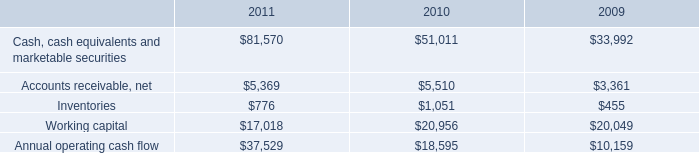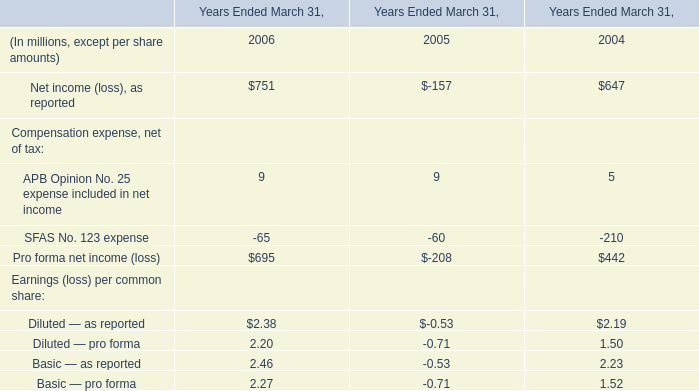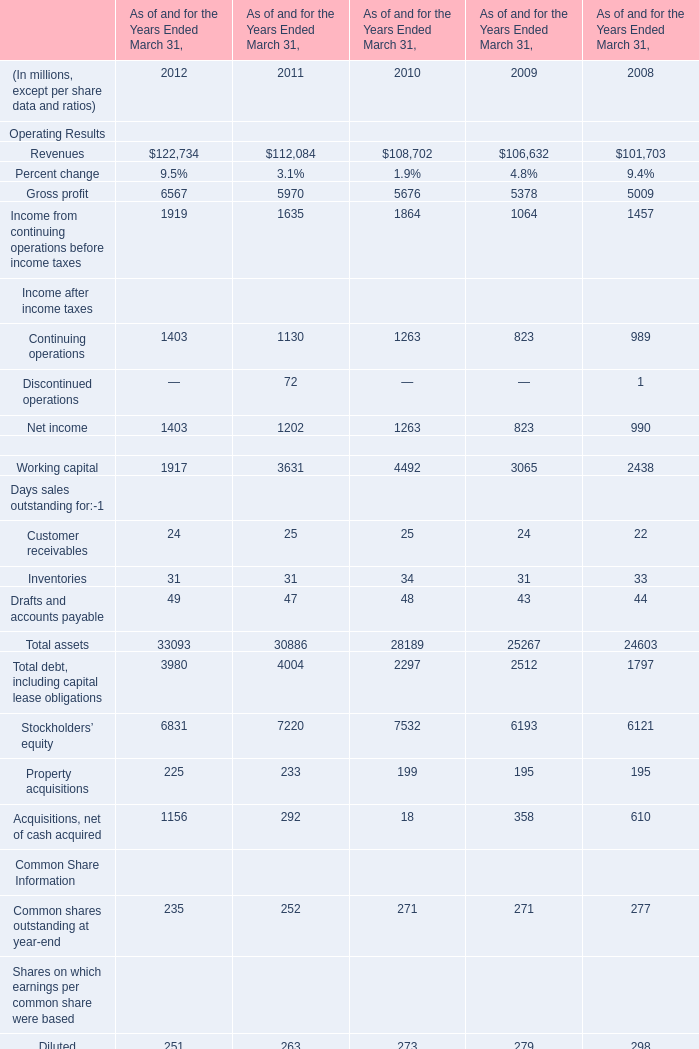what is the percentage change in annual operating cash flow from 2009 to 2010? 
Computations: ((18595 - 10159) / 10159)
Answer: 0.8304. 